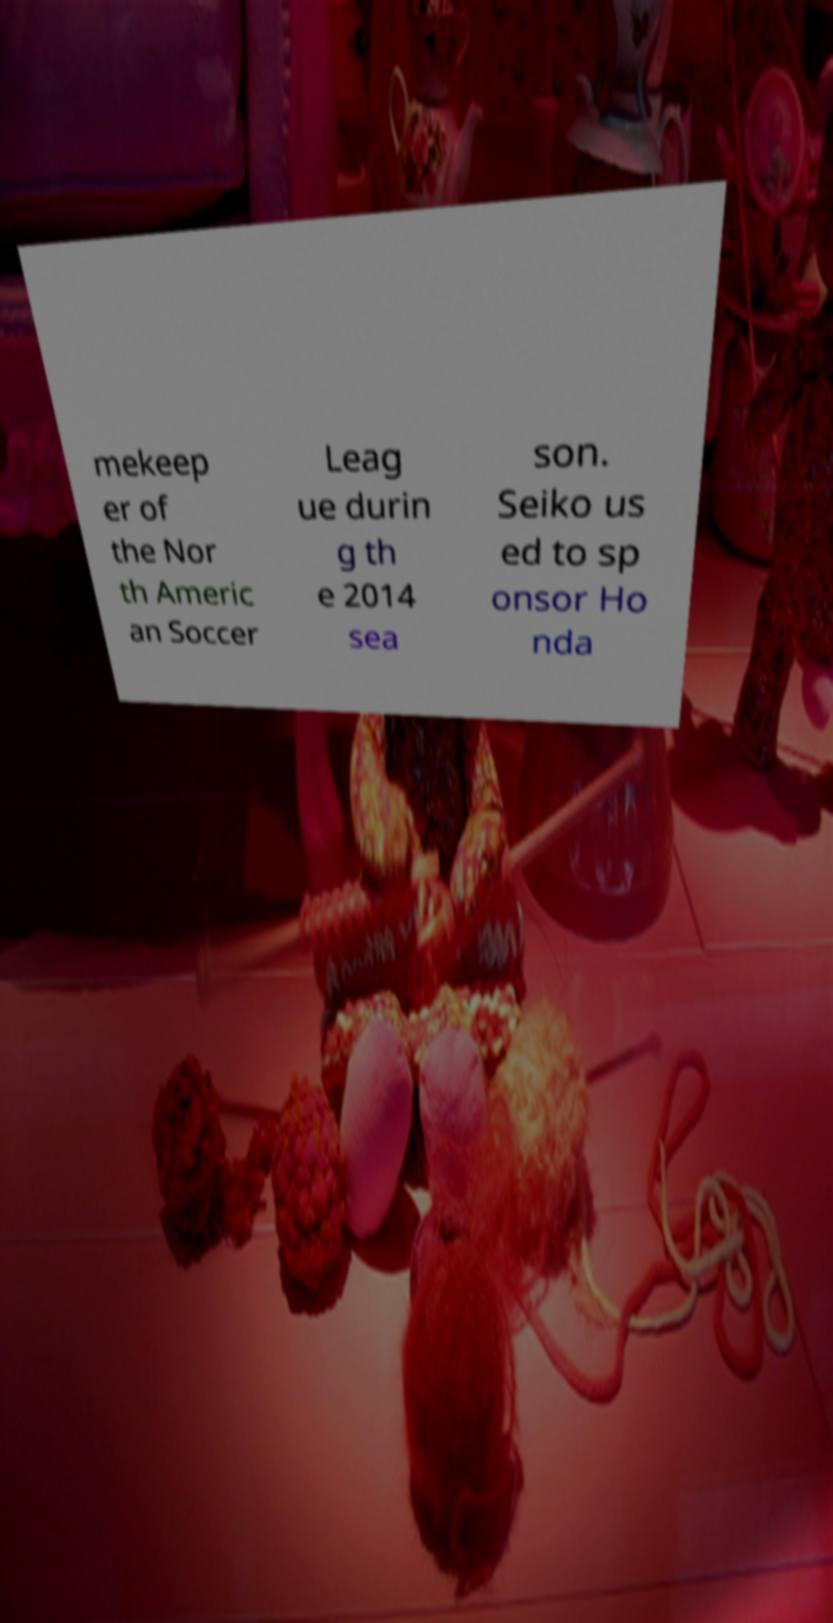Could you extract and type out the text from this image? mekeep er of the Nor th Americ an Soccer Leag ue durin g th e 2014 sea son. Seiko us ed to sp onsor Ho nda 